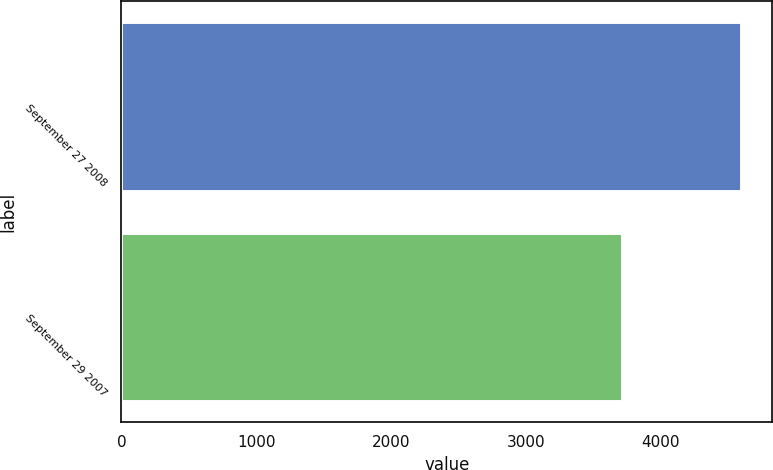<chart> <loc_0><loc_0><loc_500><loc_500><bar_chart><fcel>September 27 2008<fcel>September 29 2007<nl><fcel>4598<fcel>3712<nl></chart> 